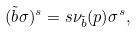Convert formula to latex. <formula><loc_0><loc_0><loc_500><loc_500>( \tilde { b } \sigma ) ^ { s } = s \nu _ { \tilde { b } } ( p ) \sigma ^ { s } ,</formula> 